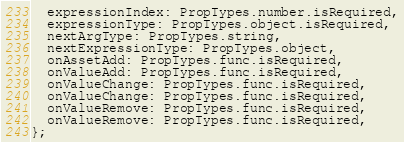Convert code to text. <code><loc_0><loc_0><loc_500><loc_500><_JavaScript_>  expressionIndex: PropTypes.number.isRequired,
  expressionType: PropTypes.object.isRequired,
  nextArgType: PropTypes.string,
  nextExpressionType: PropTypes.object,
  onAssetAdd: PropTypes.func.isRequired,
  onValueAdd: PropTypes.func.isRequired,
  onValueChange: PropTypes.func.isRequired,
  onValueChange: PropTypes.func.isRequired,
  onValueRemove: PropTypes.func.isRequired,
  onValueRemove: PropTypes.func.isRequired,
};
</code> 